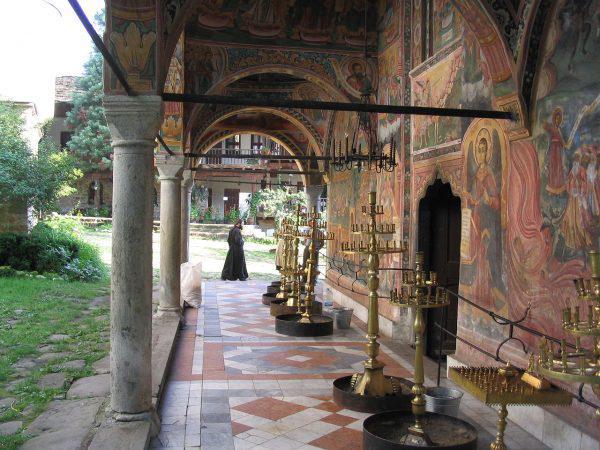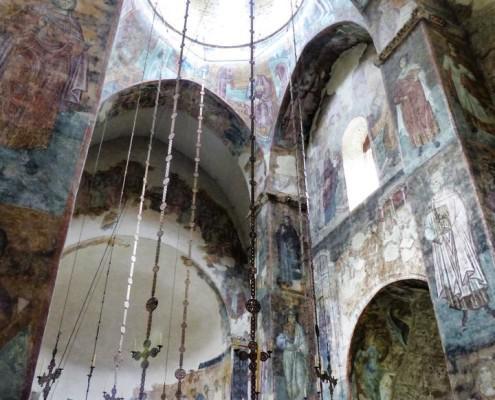The first image is the image on the left, the second image is the image on the right. For the images shown, is this caption "An image shows green lawn and a view of the outdoors through an archway." true? Answer yes or no. Yes. The first image is the image on the left, the second image is the image on the right. For the images shown, is this caption "A grassy outdoor area can be seen near the building in the image on the left." true? Answer yes or no. Yes. 